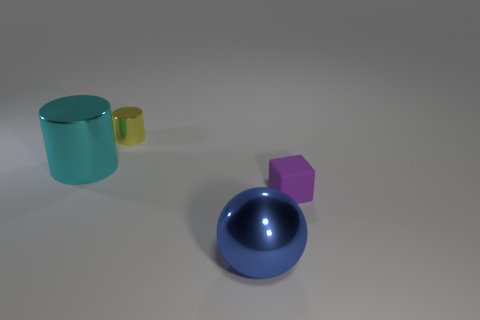There is another object that is the same shape as the large cyan metal object; what is its color?
Your answer should be very brief. Yellow. What material is the thing that is in front of the purple matte block?
Give a very brief answer. Metal. What size is the yellow thing that is the same shape as the cyan thing?
Your answer should be compact. Small. What number of tiny yellow things are the same material as the large blue sphere?
Offer a very short reply. 1. What number of metallic spheres have the same color as the big metallic cylinder?
Your response must be concise. 0. How many objects are either small things behind the purple block or big objects behind the matte block?
Provide a succinct answer. 2. Are there fewer blue shiny spheres that are behind the purple matte block than big cylinders?
Your answer should be compact. Yes. Is there a green cylinder of the same size as the ball?
Ensure brevity in your answer.  No. The big sphere is what color?
Keep it short and to the point. Blue. Do the matte cube and the yellow cylinder have the same size?
Make the answer very short. Yes. 